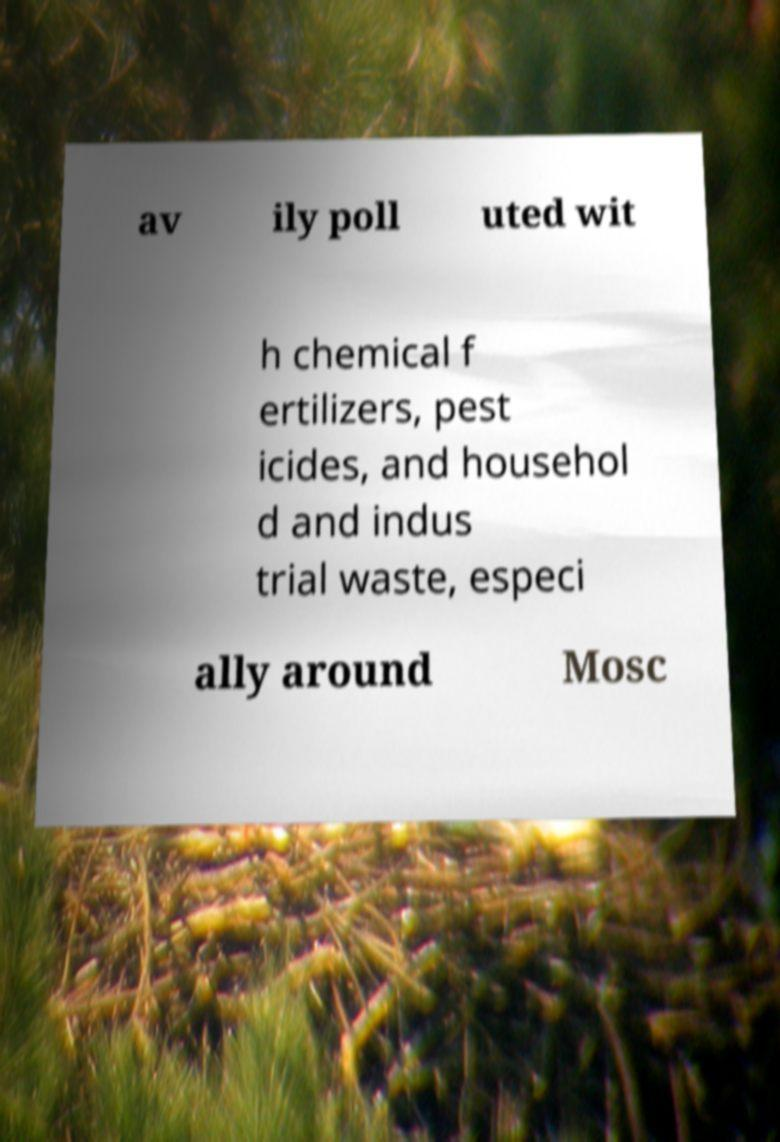I need the written content from this picture converted into text. Can you do that? av ily poll uted wit h chemical f ertilizers, pest icides, and househol d and indus trial waste, especi ally around Mosc 